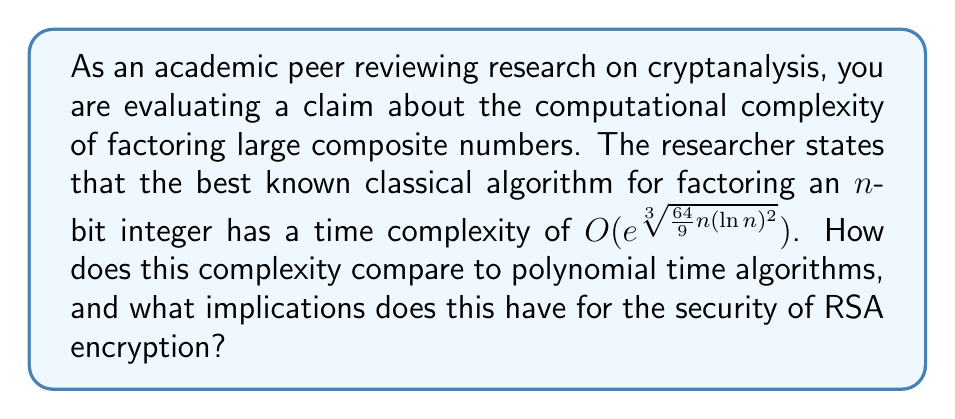Teach me how to tackle this problem. To evaluate this claim, let's break down the analysis step-by-step:

1) The given time complexity is $O(e^{\sqrt[3]{\frac{64}{9}n(\ln n)^2}})$, which is known as the complexity of the General Number Field Sieve (GNFS) algorithm.

2) To compare with polynomial time algorithms, we need to understand the growth rate of this function:

   Let $f(n) = e^{\sqrt[3]{\frac{64}{9}n(\ln n)^2}}$

3) Taking the natural log of both sides:

   $\ln(f(n)) = \sqrt[3]{\frac{64}{9}n(\ln n)^2}$

4) This is clearly superpolynomial, as it grows faster than any polynomial function of n.

5) Polynomial time algorithms have a time complexity of $O(n^k)$ for some constant k. The GNFS complexity grows much faster than this.

6) In fact, this complexity is subexponential. It grows slower than a pure exponential function $O(2^n)$, but faster than any polynomial function.

7) For RSA encryption, this implies that as the bit-length of the modulus increases, the time to factor it grows subexponentially.

8) This growth rate is slow enough to make very large numbers (e.g., 2048-bit or 4096-bit) computationally infeasible to factor with current technology, but fast enough that smaller bit lengths (e.g., 512-bit) are now considered insecure.

9) The subexponential nature of this algorithm is why RSA key sizes need to increase over time to maintain the same level of security, as computational power increases.
Answer: Subexponential; secure for large keys but requires periodic increase in key size. 